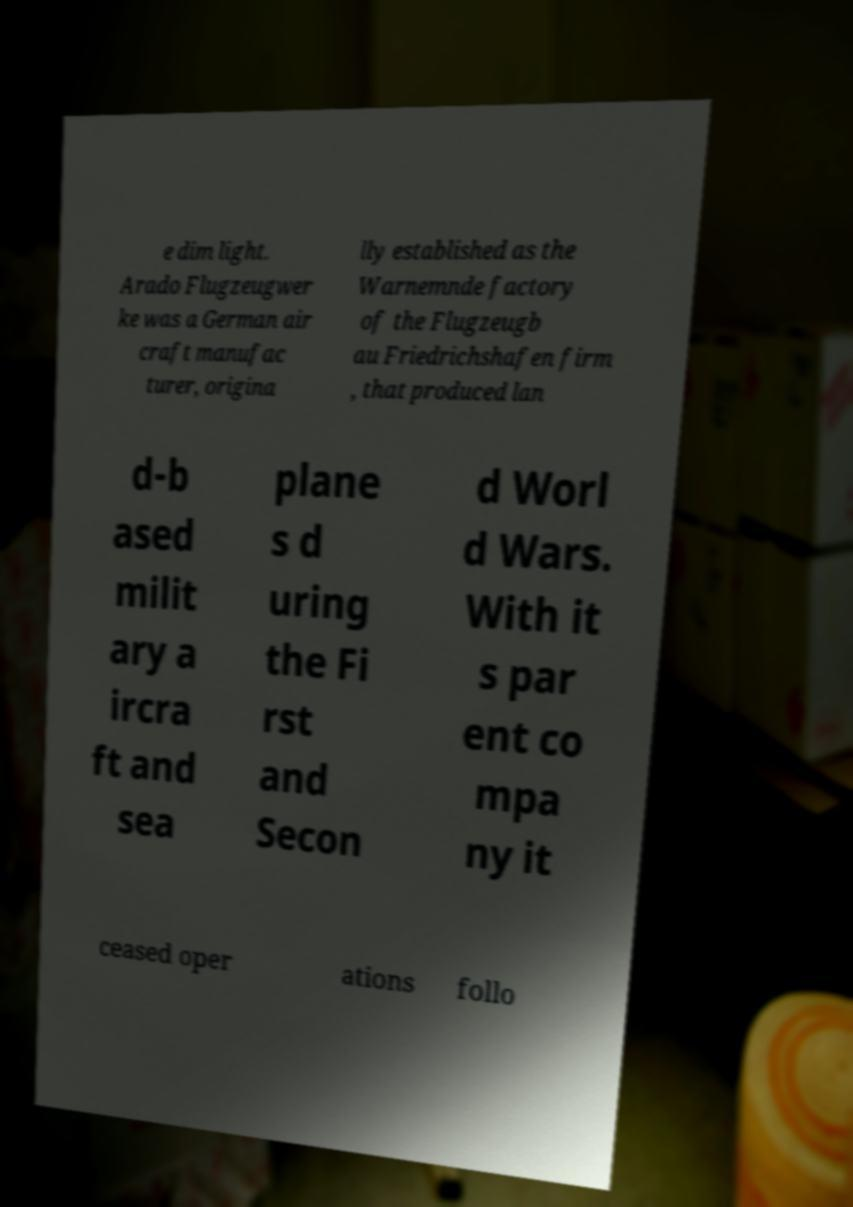Please read and relay the text visible in this image. What does it say? e dim light. Arado Flugzeugwer ke was a German air craft manufac turer, origina lly established as the Warnemnde factory of the Flugzeugb au Friedrichshafen firm , that produced lan d-b ased milit ary a ircra ft and sea plane s d uring the Fi rst and Secon d Worl d Wars. With it s par ent co mpa ny it ceased oper ations follo 